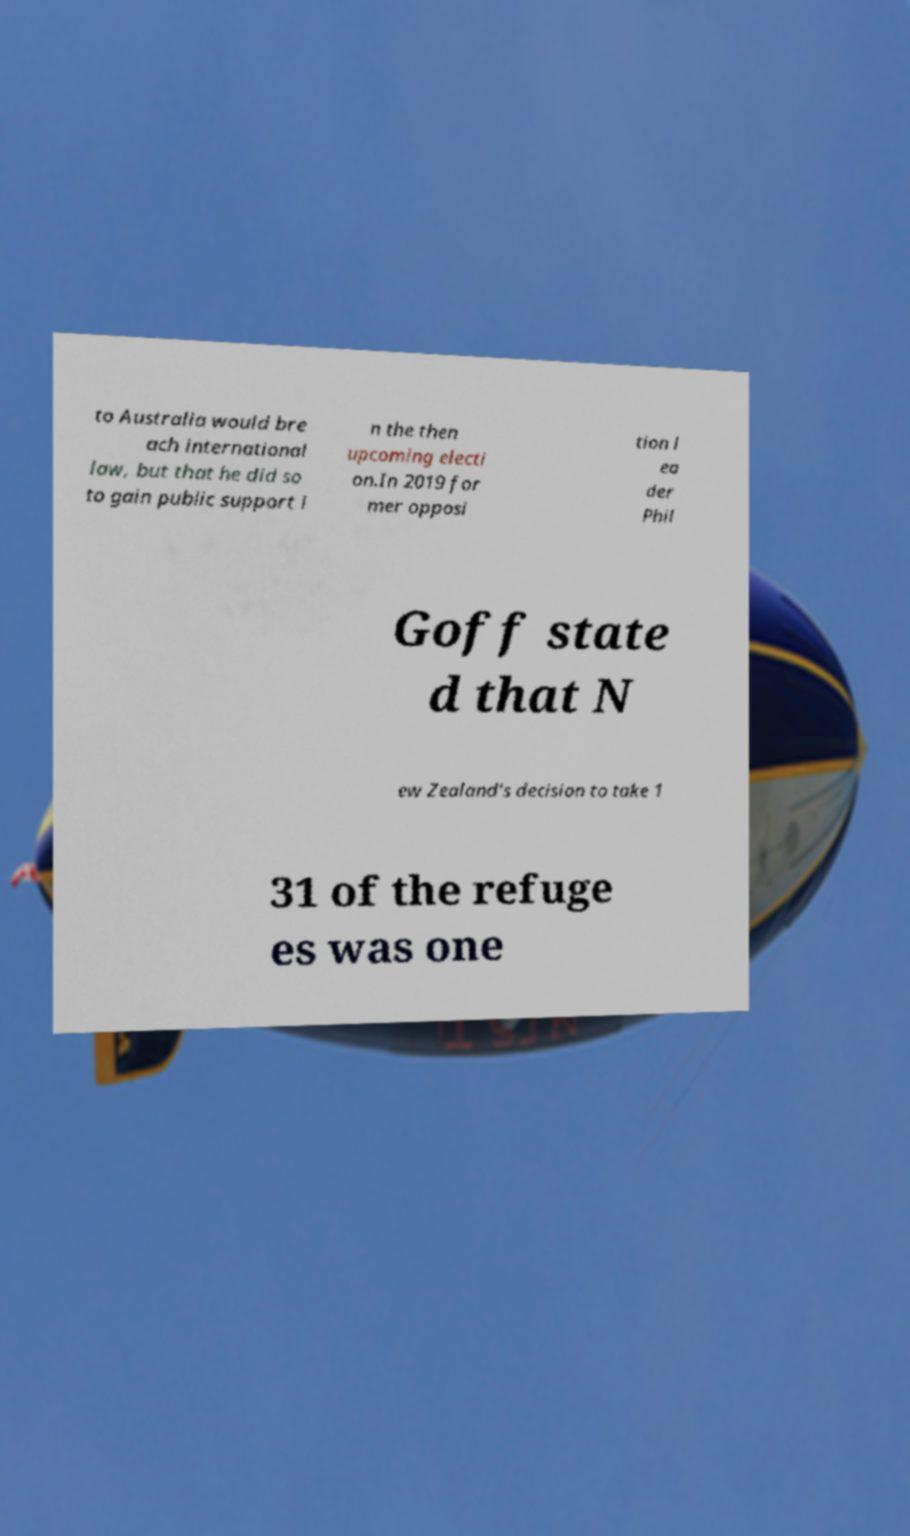Could you extract and type out the text from this image? to Australia would bre ach international law, but that he did so to gain public support i n the then upcoming electi on.In 2019 for mer opposi tion l ea der Phil Goff state d that N ew Zealand's decision to take 1 31 of the refuge es was one 